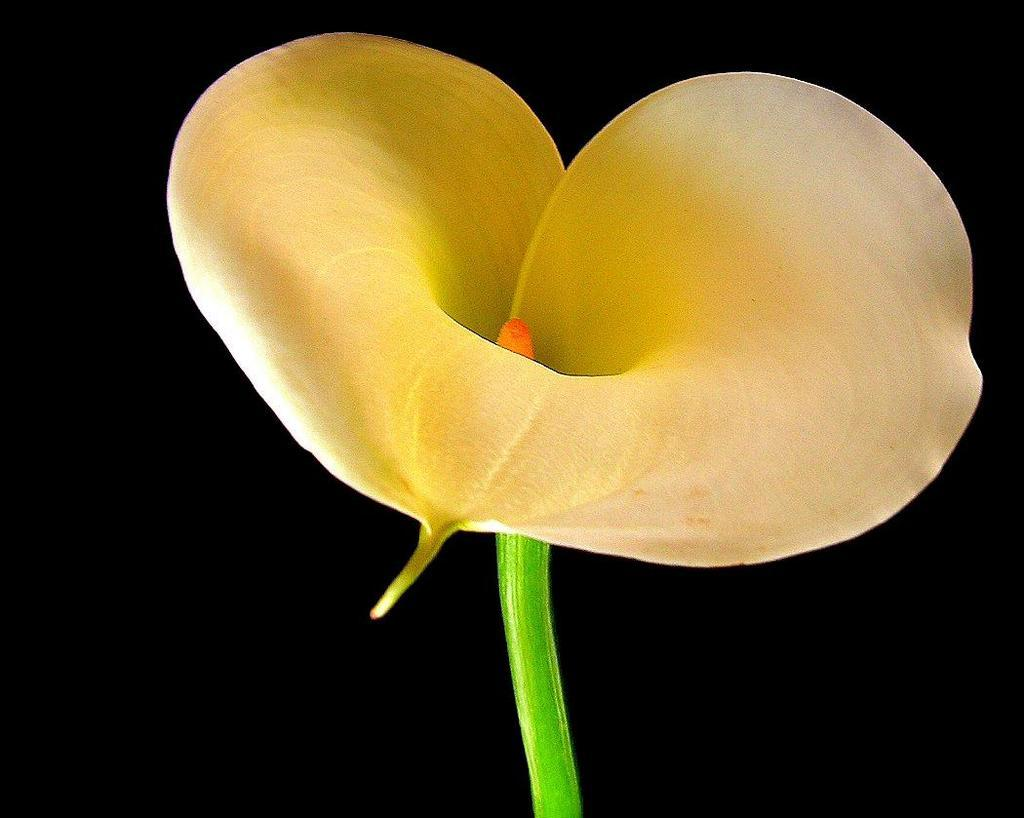What is the main subject of the image? There is a flower in the image. Can you describe the background of the image? The background of the image is dark. How many toes can be seen on the flower in the image? There are no toes present in the image, as it features a flower and not a person or animal. 